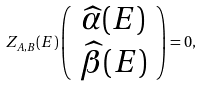<formula> <loc_0><loc_0><loc_500><loc_500>Z _ { A , B } ( E ) \left ( \begin{array} { c } \widehat { \alpha } ( E ) \\ \widehat { \beta } ( E ) \end{array} \right ) = 0 ,</formula> 